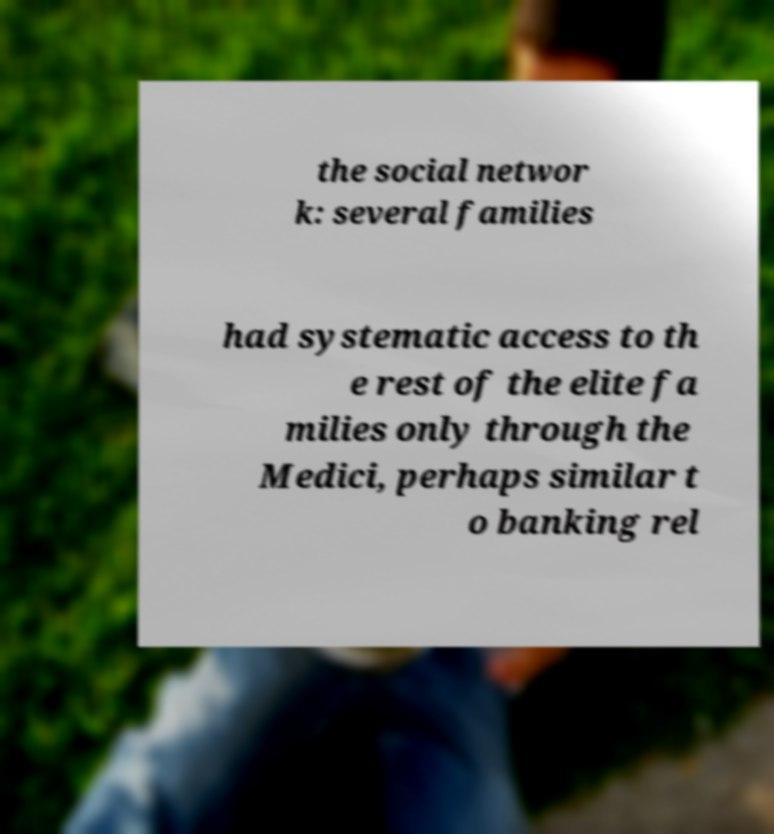Please identify and transcribe the text found in this image. the social networ k: several families had systematic access to th e rest of the elite fa milies only through the Medici, perhaps similar t o banking rel 